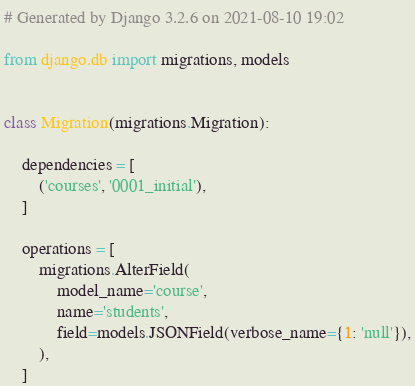Convert code to text. <code><loc_0><loc_0><loc_500><loc_500><_Python_># Generated by Django 3.2.6 on 2021-08-10 19:02

from django.db import migrations, models


class Migration(migrations.Migration):

    dependencies = [
        ('courses', '0001_initial'),
    ]

    operations = [
        migrations.AlterField(
            model_name='course',
            name='students',
            field=models.JSONField(verbose_name={1: 'null'}),
        ),
    ]
</code> 